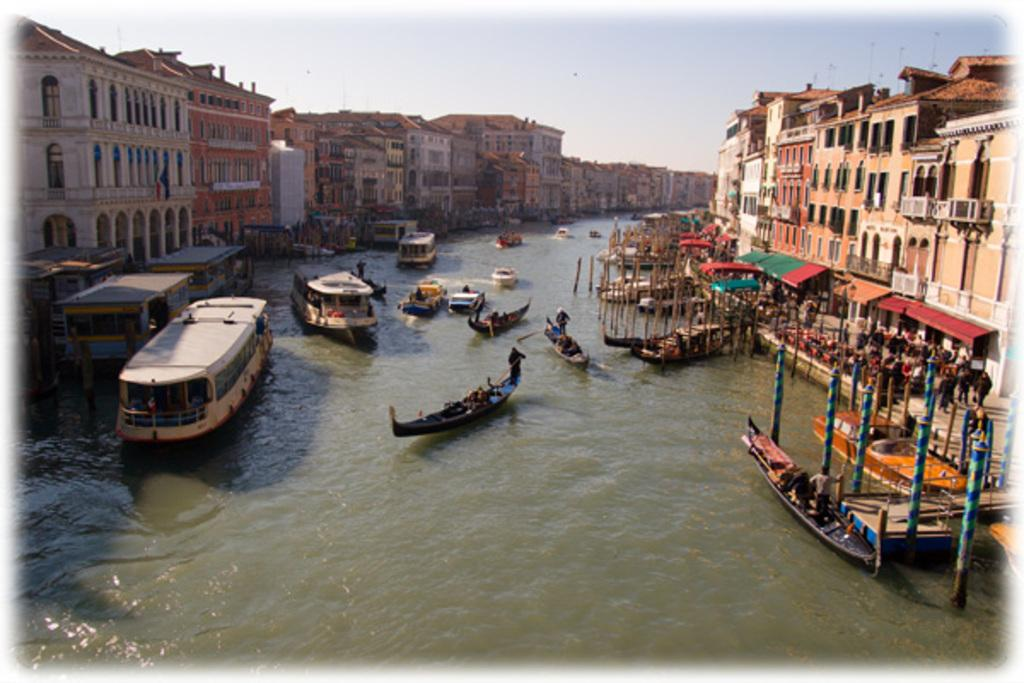What is at the bottom of the image? There is water at the bottom of the image. What is in the water? There are boats, poles, people, and tents in the water. What structures can be seen in the middle of the image? There are buildings in the middle of the image. What is visible in the sky? The sky is visible in the image. Can you see any blood dripping from the boats in the image? There is no blood present in the image; it features water, boats, poles, people, tents, buildings, and a sky. Is there a trail of cheese leading to the tents in the image? There is no trail of cheese present in the image. 